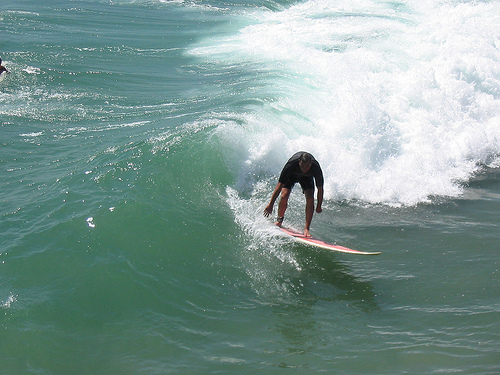How might a beginner surfer react in this environment? A beginner surfer might feel a mixture of excitement and apprehension in this environment. The powerful waves are both thrilling and daunting, offering a great opportunity for learning but also presenting significant challenges. A beginner would likely focus intensely on balancing and handling their board, learning to read the waves and adjust their movements. Despite the difficulties, the exhilaration of catching a wave, even for a brief moment, would make the experience immensely rewarding. Describe a long response scenario depicting an adventurous day of a surfer at this beach. An adventurous day at this beach begins at dawn. The surfer wakes early, driven by an insatiable passion for the waves. As the sun rises, casting a golden hue across the water, the surfer paddles out into the ocean, feeling the cool embrace of the morning sea. The first waves are small and gentle, offering a perfect warm-up. As the day progresses, the waves grow in size and intensity, presenting both a thrill and a challenge. The surfer navigates these powerful swells with skill, carving through the water with precision. Between sessions, there are moments of rest on the sandy shore, watching other surfers, sharing tips, and enjoying the camaraderie of the surfing community. At noon, the sun is high, and the waves are at their peak. The surfer catches a massive wave and rides it flawlessly to shore, a moment of triumph and elation. As the sun sets, painting the sky with brilliant shades of orange and pink, the surfer reflects on the day's adventures, already looking forward to the next day's waves. 